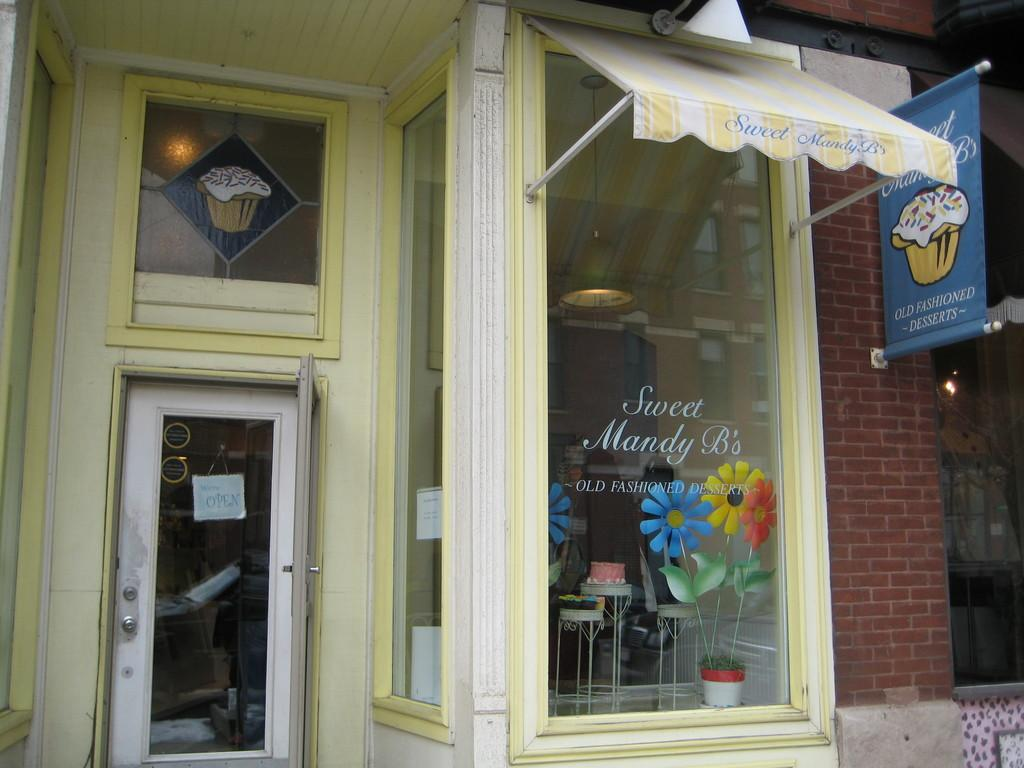What type of establishment is in the foreground of the image? There is a shop in the foreground of the image. What features does the shop have? The shop has a door and a glass window. Is there any signage on the shop? Yes, there is a banner on the shop. What additional structure is near the shop? There is a small tent near the glass window. What can be seen inside the shop? Cakes are present on stools inside the shop. What type of cup is being used to serve the idea in the image? There is no mention of an idea or a cup in the image; it features a shop with a door, glass window, banner, small tent, and cakes inside. 